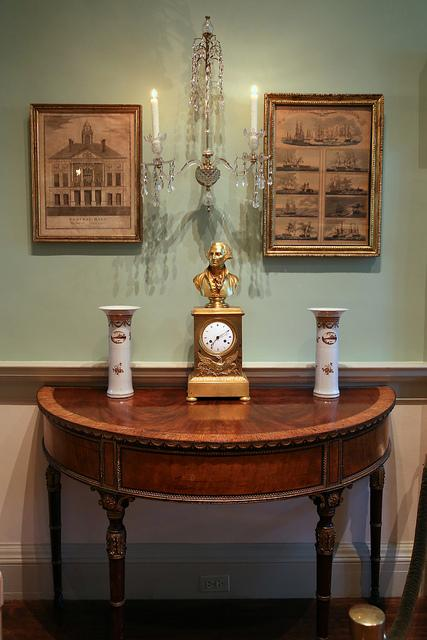How many items on the table are to the left of the clock? one 